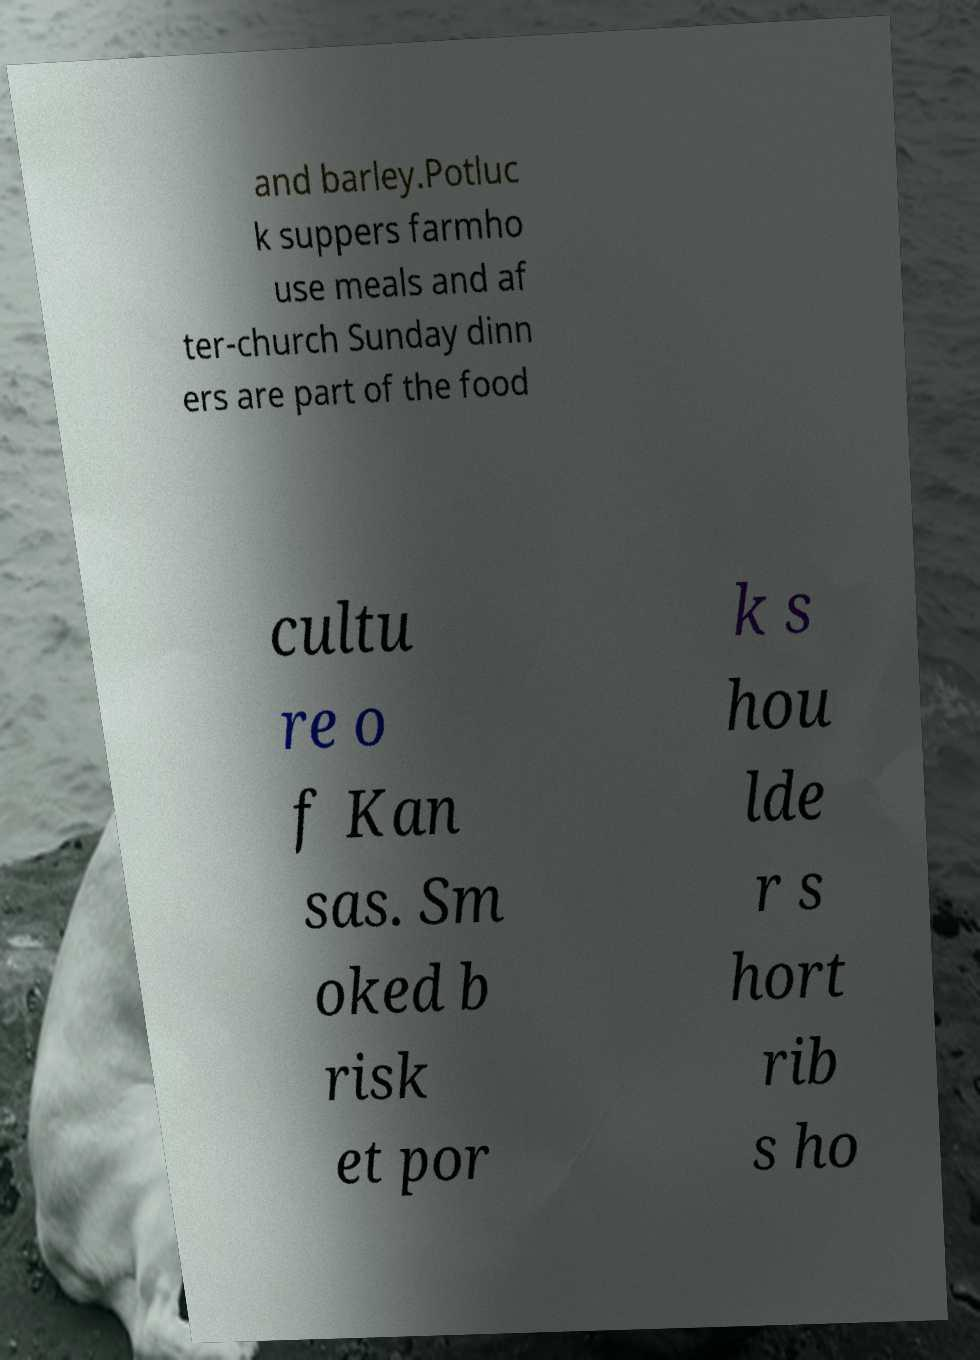Could you extract and type out the text from this image? and barley.Potluc k suppers farmho use meals and af ter-church Sunday dinn ers are part of the food cultu re o f Kan sas. Sm oked b risk et por k s hou lde r s hort rib s ho 